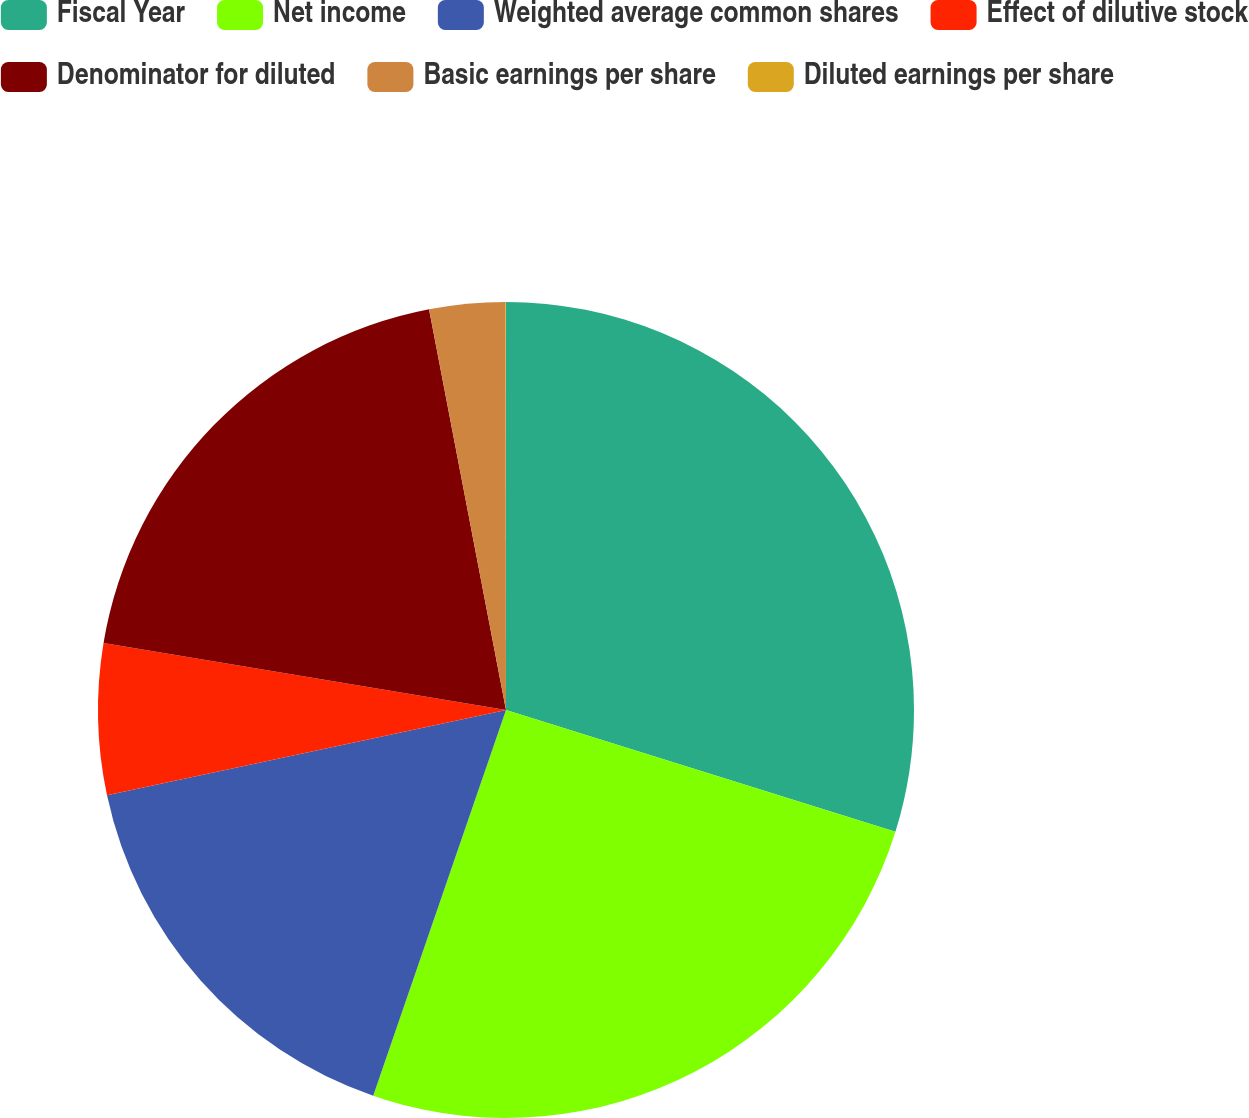Convert chart to OTSL. <chart><loc_0><loc_0><loc_500><loc_500><pie_chart><fcel>Fiscal Year<fcel>Net income<fcel>Weighted average common shares<fcel>Effect of dilutive stock<fcel>Denominator for diluted<fcel>Basic earnings per share<fcel>Diluted earnings per share<nl><fcel>29.82%<fcel>25.45%<fcel>16.37%<fcel>5.98%<fcel>19.35%<fcel>3.0%<fcel>0.02%<nl></chart> 